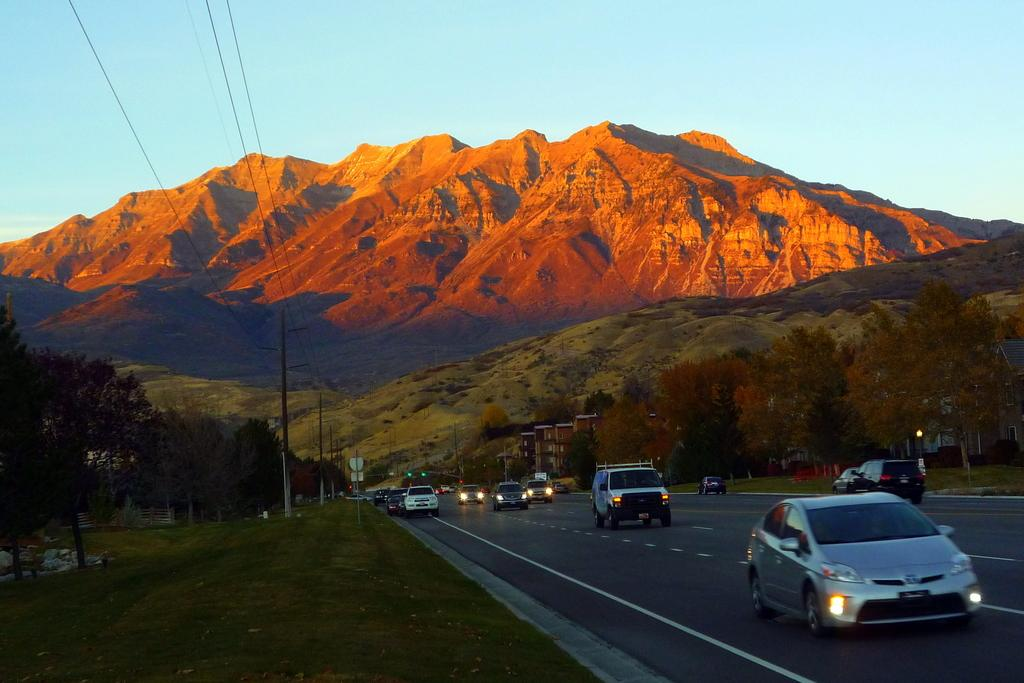What can be seen on the road in the image? There are vehicles on the road in the image. What structures are visible in the image? There are buildings visible in the image. What type of vegetation is present in the image? Trees are present in the image. What device is used to control traffic in the image? There is a traffic signal in the image. What vertical structures are visible in the image? Electric poles are visible in the image. What objects are present in the image? There are objects in the image. What natural features can be seen in the background of the image? There are mountains visible in the background of the image. What part of the natural environment is visible in the background of the image? The sky is visible in the background of the image. What is the name of the daughter of the writer in the image? There is no daughter or writer present in the image. What type of pen does the writer use in the image? There is no writer or pen present in the image. 